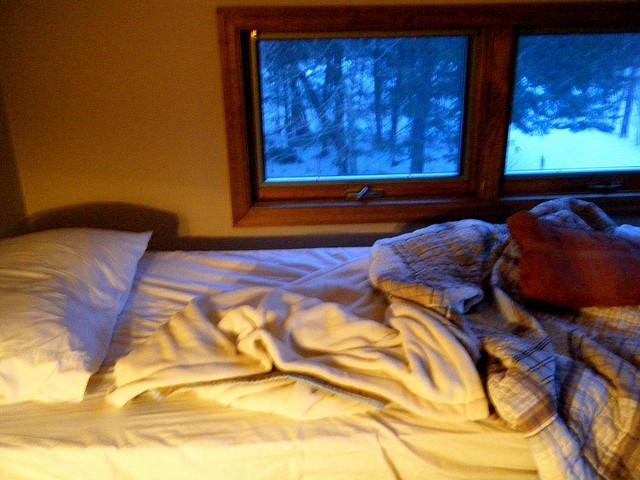What season is it?
Answer briefly. Winter. Is the bed made?
Short answer required. No. Is someone sleeping in the bed?
Concise answer only. No. 